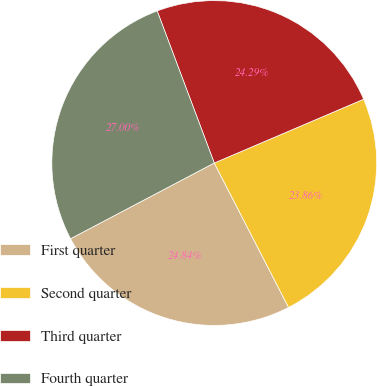Convert chart to OTSL. <chart><loc_0><loc_0><loc_500><loc_500><pie_chart><fcel>First quarter<fcel>Second quarter<fcel>Third quarter<fcel>Fourth quarter<nl><fcel>24.84%<fcel>23.86%<fcel>24.29%<fcel>27.0%<nl></chart> 